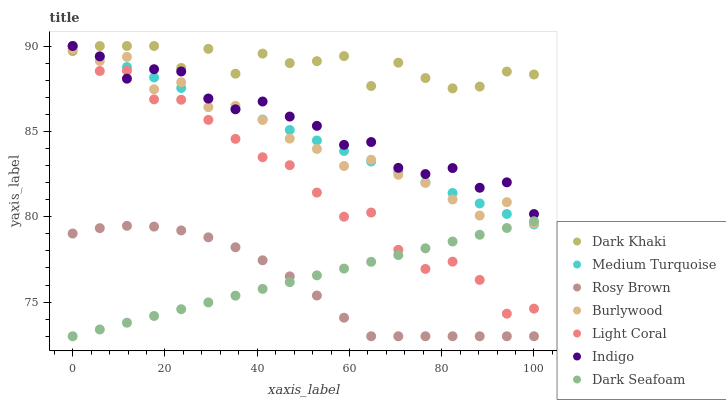Does Rosy Brown have the minimum area under the curve?
Answer yes or no. Yes. Does Dark Khaki have the maximum area under the curve?
Answer yes or no. Yes. Does Indigo have the minimum area under the curve?
Answer yes or no. No. Does Indigo have the maximum area under the curve?
Answer yes or no. No. Is Medium Turquoise the smoothest?
Answer yes or no. Yes. Is Dark Khaki the roughest?
Answer yes or no. Yes. Is Indigo the smoothest?
Answer yes or no. No. Is Indigo the roughest?
Answer yes or no. No. Does Rosy Brown have the lowest value?
Answer yes or no. Yes. Does Indigo have the lowest value?
Answer yes or no. No. Does Medium Turquoise have the highest value?
Answer yes or no. Yes. Does Burlywood have the highest value?
Answer yes or no. No. Is Rosy Brown less than Medium Turquoise?
Answer yes or no. Yes. Is Light Coral greater than Rosy Brown?
Answer yes or no. Yes. Does Dark Seafoam intersect Rosy Brown?
Answer yes or no. Yes. Is Dark Seafoam less than Rosy Brown?
Answer yes or no. No. Is Dark Seafoam greater than Rosy Brown?
Answer yes or no. No. Does Rosy Brown intersect Medium Turquoise?
Answer yes or no. No. 